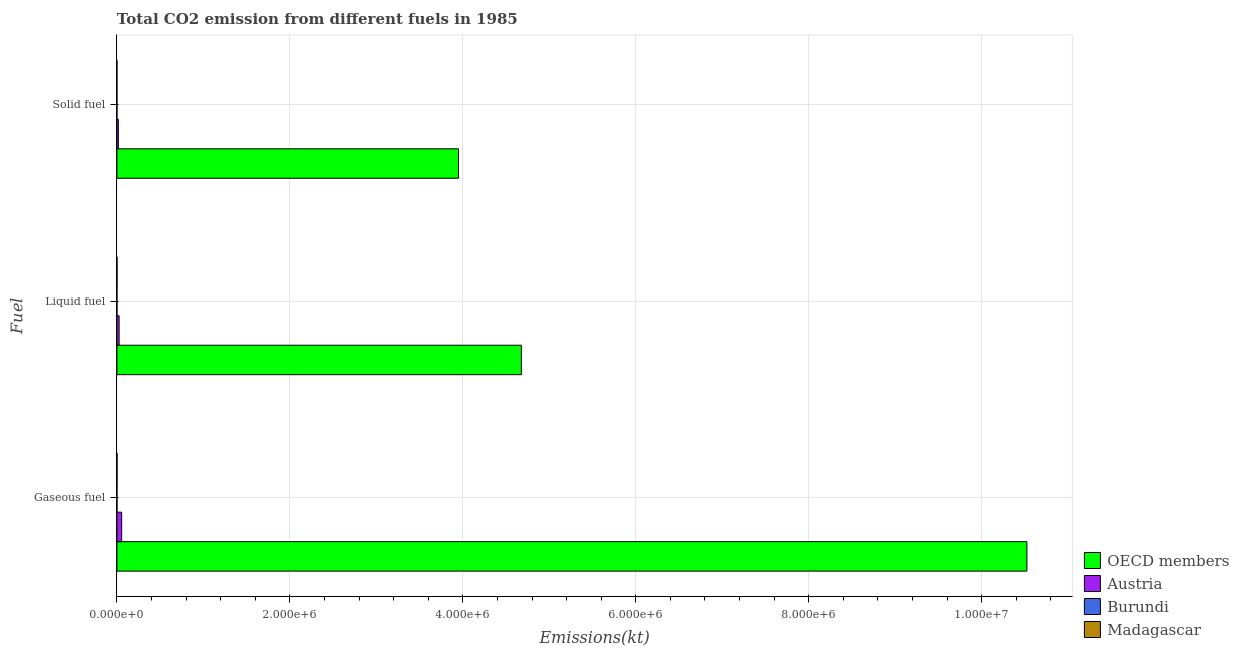How many different coloured bars are there?
Your answer should be very brief. 4. Are the number of bars per tick equal to the number of legend labels?
Offer a very short reply. Yes. How many bars are there on the 2nd tick from the bottom?
Ensure brevity in your answer.  4. What is the label of the 1st group of bars from the top?
Provide a succinct answer. Solid fuel. What is the amount of co2 emissions from gaseous fuel in Burundi?
Your answer should be compact. 231.02. Across all countries, what is the maximum amount of co2 emissions from liquid fuel?
Give a very brief answer. 4.68e+06. Across all countries, what is the minimum amount of co2 emissions from liquid fuel?
Offer a very short reply. 216.35. In which country was the amount of co2 emissions from liquid fuel minimum?
Provide a succinct answer. Burundi. What is the total amount of co2 emissions from gaseous fuel in the graph?
Keep it short and to the point. 1.06e+07. What is the difference between the amount of co2 emissions from gaseous fuel in Madagascar and that in Burundi?
Your answer should be compact. 850.74. What is the difference between the amount of co2 emissions from solid fuel in Madagascar and the amount of co2 emissions from gaseous fuel in OECD members?
Make the answer very short. -1.05e+07. What is the average amount of co2 emissions from gaseous fuel per country?
Offer a terse response. 2.64e+06. What is the difference between the amount of co2 emissions from solid fuel and amount of co2 emissions from liquid fuel in Madagascar?
Give a very brief answer. -1041.43. In how many countries, is the amount of co2 emissions from solid fuel greater than 7600000 kt?
Provide a succinct answer. 0. What is the ratio of the amount of co2 emissions from liquid fuel in Burundi to that in Madagascar?
Ensure brevity in your answer.  0.21. Is the amount of co2 emissions from liquid fuel in OECD members less than that in Madagascar?
Keep it short and to the point. No. Is the difference between the amount of co2 emissions from gaseous fuel in Burundi and Madagascar greater than the difference between the amount of co2 emissions from solid fuel in Burundi and Madagascar?
Provide a short and direct response. No. What is the difference between the highest and the second highest amount of co2 emissions from liquid fuel?
Offer a terse response. 4.65e+06. What is the difference between the highest and the lowest amount of co2 emissions from solid fuel?
Provide a succinct answer. 3.95e+06. What does the 4th bar from the top in Solid fuel represents?
Ensure brevity in your answer.  OECD members. What does the 4th bar from the bottom in Liquid fuel represents?
Your response must be concise. Madagascar. Is it the case that in every country, the sum of the amount of co2 emissions from gaseous fuel and amount of co2 emissions from liquid fuel is greater than the amount of co2 emissions from solid fuel?
Offer a very short reply. Yes. Are all the bars in the graph horizontal?
Your response must be concise. Yes. What is the difference between two consecutive major ticks on the X-axis?
Your response must be concise. 2.00e+06. Are the values on the major ticks of X-axis written in scientific E-notation?
Your response must be concise. Yes. Does the graph contain any zero values?
Provide a succinct answer. No. Does the graph contain grids?
Make the answer very short. Yes. How are the legend labels stacked?
Make the answer very short. Vertical. What is the title of the graph?
Provide a succinct answer. Total CO2 emission from different fuels in 1985. Does "Korea (Republic)" appear as one of the legend labels in the graph?
Provide a short and direct response. No. What is the label or title of the X-axis?
Ensure brevity in your answer.  Emissions(kt). What is the label or title of the Y-axis?
Give a very brief answer. Fuel. What is the Emissions(kt) in OECD members in Gaseous fuel?
Offer a terse response. 1.05e+07. What is the Emissions(kt) of Austria in Gaseous fuel?
Your answer should be compact. 5.47e+04. What is the Emissions(kt) in Burundi in Gaseous fuel?
Provide a short and direct response. 231.02. What is the Emissions(kt) of Madagascar in Gaseous fuel?
Your answer should be compact. 1081.77. What is the Emissions(kt) of OECD members in Liquid fuel?
Your answer should be very brief. 4.68e+06. What is the Emissions(kt) in Austria in Liquid fuel?
Your answer should be very brief. 2.53e+04. What is the Emissions(kt) of Burundi in Liquid fuel?
Make the answer very short. 216.35. What is the Emissions(kt) in Madagascar in Liquid fuel?
Keep it short and to the point. 1052.43. What is the Emissions(kt) of OECD members in Solid fuel?
Ensure brevity in your answer.  3.95e+06. What is the Emissions(kt) in Austria in Solid fuel?
Provide a succinct answer. 1.67e+04. What is the Emissions(kt) of Burundi in Solid fuel?
Your answer should be very brief. 14.67. What is the Emissions(kt) in Madagascar in Solid fuel?
Ensure brevity in your answer.  11. Across all Fuel, what is the maximum Emissions(kt) of OECD members?
Your answer should be very brief. 1.05e+07. Across all Fuel, what is the maximum Emissions(kt) of Austria?
Offer a terse response. 5.47e+04. Across all Fuel, what is the maximum Emissions(kt) in Burundi?
Offer a terse response. 231.02. Across all Fuel, what is the maximum Emissions(kt) in Madagascar?
Keep it short and to the point. 1081.77. Across all Fuel, what is the minimum Emissions(kt) in OECD members?
Make the answer very short. 3.95e+06. Across all Fuel, what is the minimum Emissions(kt) of Austria?
Offer a very short reply. 1.67e+04. Across all Fuel, what is the minimum Emissions(kt) of Burundi?
Your answer should be very brief. 14.67. Across all Fuel, what is the minimum Emissions(kt) in Madagascar?
Give a very brief answer. 11. What is the total Emissions(kt) of OECD members in the graph?
Your answer should be compact. 1.91e+07. What is the total Emissions(kt) of Austria in the graph?
Your answer should be very brief. 9.67e+04. What is the total Emissions(kt) of Burundi in the graph?
Ensure brevity in your answer.  462.04. What is the total Emissions(kt) in Madagascar in the graph?
Offer a very short reply. 2145.2. What is the difference between the Emissions(kt) of OECD members in Gaseous fuel and that in Liquid fuel?
Your response must be concise. 5.85e+06. What is the difference between the Emissions(kt) in Austria in Gaseous fuel and that in Liquid fuel?
Offer a terse response. 2.94e+04. What is the difference between the Emissions(kt) in Burundi in Gaseous fuel and that in Liquid fuel?
Your answer should be very brief. 14.67. What is the difference between the Emissions(kt) of Madagascar in Gaseous fuel and that in Liquid fuel?
Make the answer very short. 29.34. What is the difference between the Emissions(kt) of OECD members in Gaseous fuel and that in Solid fuel?
Provide a succinct answer. 6.57e+06. What is the difference between the Emissions(kt) in Austria in Gaseous fuel and that in Solid fuel?
Provide a short and direct response. 3.80e+04. What is the difference between the Emissions(kt) in Burundi in Gaseous fuel and that in Solid fuel?
Offer a very short reply. 216.35. What is the difference between the Emissions(kt) in Madagascar in Gaseous fuel and that in Solid fuel?
Provide a short and direct response. 1070.76. What is the difference between the Emissions(kt) in OECD members in Liquid fuel and that in Solid fuel?
Keep it short and to the point. 7.27e+05. What is the difference between the Emissions(kt) of Austria in Liquid fuel and that in Solid fuel?
Keep it short and to the point. 8676.12. What is the difference between the Emissions(kt) of Burundi in Liquid fuel and that in Solid fuel?
Ensure brevity in your answer.  201.69. What is the difference between the Emissions(kt) in Madagascar in Liquid fuel and that in Solid fuel?
Offer a very short reply. 1041.43. What is the difference between the Emissions(kt) in OECD members in Gaseous fuel and the Emissions(kt) in Austria in Liquid fuel?
Your answer should be compact. 1.05e+07. What is the difference between the Emissions(kt) of OECD members in Gaseous fuel and the Emissions(kt) of Burundi in Liquid fuel?
Make the answer very short. 1.05e+07. What is the difference between the Emissions(kt) in OECD members in Gaseous fuel and the Emissions(kt) in Madagascar in Liquid fuel?
Your answer should be very brief. 1.05e+07. What is the difference between the Emissions(kt) of Austria in Gaseous fuel and the Emissions(kt) of Burundi in Liquid fuel?
Give a very brief answer. 5.45e+04. What is the difference between the Emissions(kt) of Austria in Gaseous fuel and the Emissions(kt) of Madagascar in Liquid fuel?
Your answer should be compact. 5.36e+04. What is the difference between the Emissions(kt) in Burundi in Gaseous fuel and the Emissions(kt) in Madagascar in Liquid fuel?
Offer a very short reply. -821.41. What is the difference between the Emissions(kt) of OECD members in Gaseous fuel and the Emissions(kt) of Austria in Solid fuel?
Offer a very short reply. 1.05e+07. What is the difference between the Emissions(kt) of OECD members in Gaseous fuel and the Emissions(kt) of Burundi in Solid fuel?
Offer a terse response. 1.05e+07. What is the difference between the Emissions(kt) of OECD members in Gaseous fuel and the Emissions(kt) of Madagascar in Solid fuel?
Keep it short and to the point. 1.05e+07. What is the difference between the Emissions(kt) of Austria in Gaseous fuel and the Emissions(kt) of Burundi in Solid fuel?
Your answer should be compact. 5.47e+04. What is the difference between the Emissions(kt) of Austria in Gaseous fuel and the Emissions(kt) of Madagascar in Solid fuel?
Ensure brevity in your answer.  5.47e+04. What is the difference between the Emissions(kt) of Burundi in Gaseous fuel and the Emissions(kt) of Madagascar in Solid fuel?
Your response must be concise. 220.02. What is the difference between the Emissions(kt) of OECD members in Liquid fuel and the Emissions(kt) of Austria in Solid fuel?
Offer a very short reply. 4.66e+06. What is the difference between the Emissions(kt) in OECD members in Liquid fuel and the Emissions(kt) in Burundi in Solid fuel?
Give a very brief answer. 4.68e+06. What is the difference between the Emissions(kt) of OECD members in Liquid fuel and the Emissions(kt) of Madagascar in Solid fuel?
Give a very brief answer. 4.68e+06. What is the difference between the Emissions(kt) in Austria in Liquid fuel and the Emissions(kt) in Burundi in Solid fuel?
Ensure brevity in your answer.  2.53e+04. What is the difference between the Emissions(kt) in Austria in Liquid fuel and the Emissions(kt) in Madagascar in Solid fuel?
Give a very brief answer. 2.53e+04. What is the difference between the Emissions(kt) in Burundi in Liquid fuel and the Emissions(kt) in Madagascar in Solid fuel?
Ensure brevity in your answer.  205.35. What is the average Emissions(kt) in OECD members per Fuel?
Offer a terse response. 6.38e+06. What is the average Emissions(kt) of Austria per Fuel?
Make the answer very short. 3.22e+04. What is the average Emissions(kt) of Burundi per Fuel?
Provide a succinct answer. 154.01. What is the average Emissions(kt) in Madagascar per Fuel?
Make the answer very short. 715.07. What is the difference between the Emissions(kt) of OECD members and Emissions(kt) of Austria in Gaseous fuel?
Your response must be concise. 1.05e+07. What is the difference between the Emissions(kt) in OECD members and Emissions(kt) in Burundi in Gaseous fuel?
Provide a short and direct response. 1.05e+07. What is the difference between the Emissions(kt) of OECD members and Emissions(kt) of Madagascar in Gaseous fuel?
Make the answer very short. 1.05e+07. What is the difference between the Emissions(kt) of Austria and Emissions(kt) of Burundi in Gaseous fuel?
Your response must be concise. 5.45e+04. What is the difference between the Emissions(kt) in Austria and Emissions(kt) in Madagascar in Gaseous fuel?
Ensure brevity in your answer.  5.36e+04. What is the difference between the Emissions(kt) of Burundi and Emissions(kt) of Madagascar in Gaseous fuel?
Your response must be concise. -850.74. What is the difference between the Emissions(kt) in OECD members and Emissions(kt) in Austria in Liquid fuel?
Provide a succinct answer. 4.65e+06. What is the difference between the Emissions(kt) of OECD members and Emissions(kt) of Burundi in Liquid fuel?
Your response must be concise. 4.68e+06. What is the difference between the Emissions(kt) in OECD members and Emissions(kt) in Madagascar in Liquid fuel?
Make the answer very short. 4.68e+06. What is the difference between the Emissions(kt) in Austria and Emissions(kt) in Burundi in Liquid fuel?
Your answer should be compact. 2.51e+04. What is the difference between the Emissions(kt) of Austria and Emissions(kt) of Madagascar in Liquid fuel?
Provide a short and direct response. 2.43e+04. What is the difference between the Emissions(kt) in Burundi and Emissions(kt) in Madagascar in Liquid fuel?
Give a very brief answer. -836.08. What is the difference between the Emissions(kt) of OECD members and Emissions(kt) of Austria in Solid fuel?
Your response must be concise. 3.93e+06. What is the difference between the Emissions(kt) of OECD members and Emissions(kt) of Burundi in Solid fuel?
Offer a terse response. 3.95e+06. What is the difference between the Emissions(kt) of OECD members and Emissions(kt) of Madagascar in Solid fuel?
Provide a succinct answer. 3.95e+06. What is the difference between the Emissions(kt) of Austria and Emissions(kt) of Burundi in Solid fuel?
Give a very brief answer. 1.67e+04. What is the difference between the Emissions(kt) in Austria and Emissions(kt) in Madagascar in Solid fuel?
Ensure brevity in your answer.  1.67e+04. What is the difference between the Emissions(kt) in Burundi and Emissions(kt) in Madagascar in Solid fuel?
Give a very brief answer. 3.67. What is the ratio of the Emissions(kt) in OECD members in Gaseous fuel to that in Liquid fuel?
Your response must be concise. 2.25. What is the ratio of the Emissions(kt) of Austria in Gaseous fuel to that in Liquid fuel?
Offer a very short reply. 2.16. What is the ratio of the Emissions(kt) in Burundi in Gaseous fuel to that in Liquid fuel?
Provide a succinct answer. 1.07. What is the ratio of the Emissions(kt) in Madagascar in Gaseous fuel to that in Liquid fuel?
Your response must be concise. 1.03. What is the ratio of the Emissions(kt) of OECD members in Gaseous fuel to that in Solid fuel?
Keep it short and to the point. 2.66. What is the ratio of the Emissions(kt) in Austria in Gaseous fuel to that in Solid fuel?
Make the answer very short. 3.28. What is the ratio of the Emissions(kt) in Burundi in Gaseous fuel to that in Solid fuel?
Give a very brief answer. 15.75. What is the ratio of the Emissions(kt) in Madagascar in Gaseous fuel to that in Solid fuel?
Your answer should be very brief. 98.33. What is the ratio of the Emissions(kt) of OECD members in Liquid fuel to that in Solid fuel?
Make the answer very short. 1.18. What is the ratio of the Emissions(kt) in Austria in Liquid fuel to that in Solid fuel?
Make the answer very short. 1.52. What is the ratio of the Emissions(kt) in Burundi in Liquid fuel to that in Solid fuel?
Provide a succinct answer. 14.75. What is the ratio of the Emissions(kt) in Madagascar in Liquid fuel to that in Solid fuel?
Make the answer very short. 95.67. What is the difference between the highest and the second highest Emissions(kt) in OECD members?
Keep it short and to the point. 5.85e+06. What is the difference between the highest and the second highest Emissions(kt) of Austria?
Give a very brief answer. 2.94e+04. What is the difference between the highest and the second highest Emissions(kt) in Burundi?
Ensure brevity in your answer.  14.67. What is the difference between the highest and the second highest Emissions(kt) in Madagascar?
Your answer should be compact. 29.34. What is the difference between the highest and the lowest Emissions(kt) in OECD members?
Give a very brief answer. 6.57e+06. What is the difference between the highest and the lowest Emissions(kt) in Austria?
Keep it short and to the point. 3.80e+04. What is the difference between the highest and the lowest Emissions(kt) of Burundi?
Make the answer very short. 216.35. What is the difference between the highest and the lowest Emissions(kt) in Madagascar?
Offer a very short reply. 1070.76. 